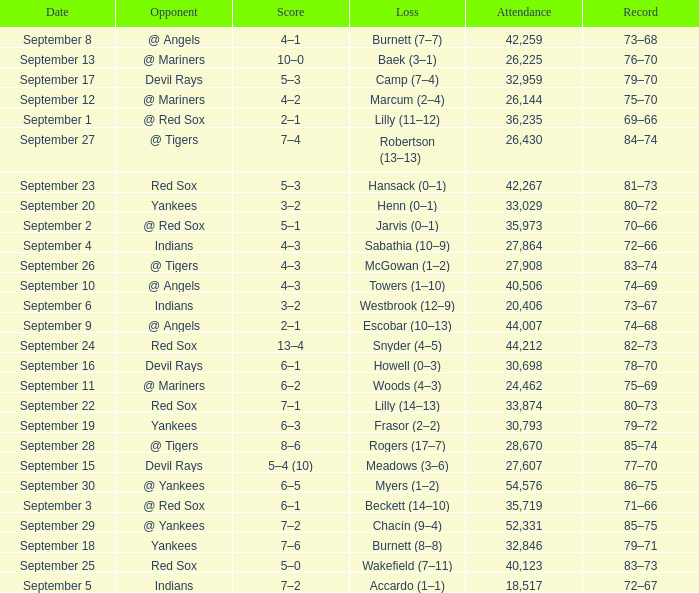Which opponent plays on September 19? Yankees. 